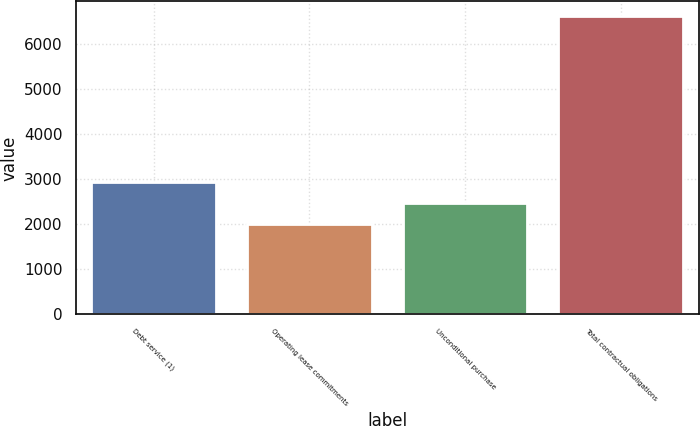Convert chart to OTSL. <chart><loc_0><loc_0><loc_500><loc_500><bar_chart><fcel>Debt service (1)<fcel>Operating lease commitments<fcel>Unconditional purchase<fcel>Total contractual obligations<nl><fcel>2932.96<fcel>2010.6<fcel>2471.78<fcel>6622.4<nl></chart> 